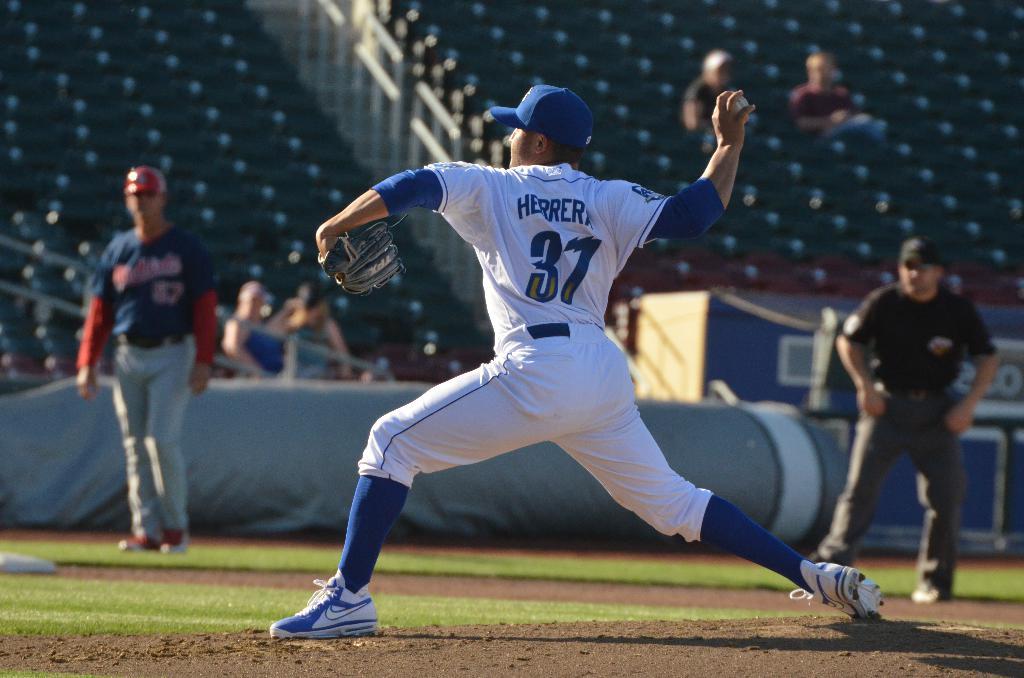What is the number on the back of the players jersey?
Keep it short and to the point. 37. 